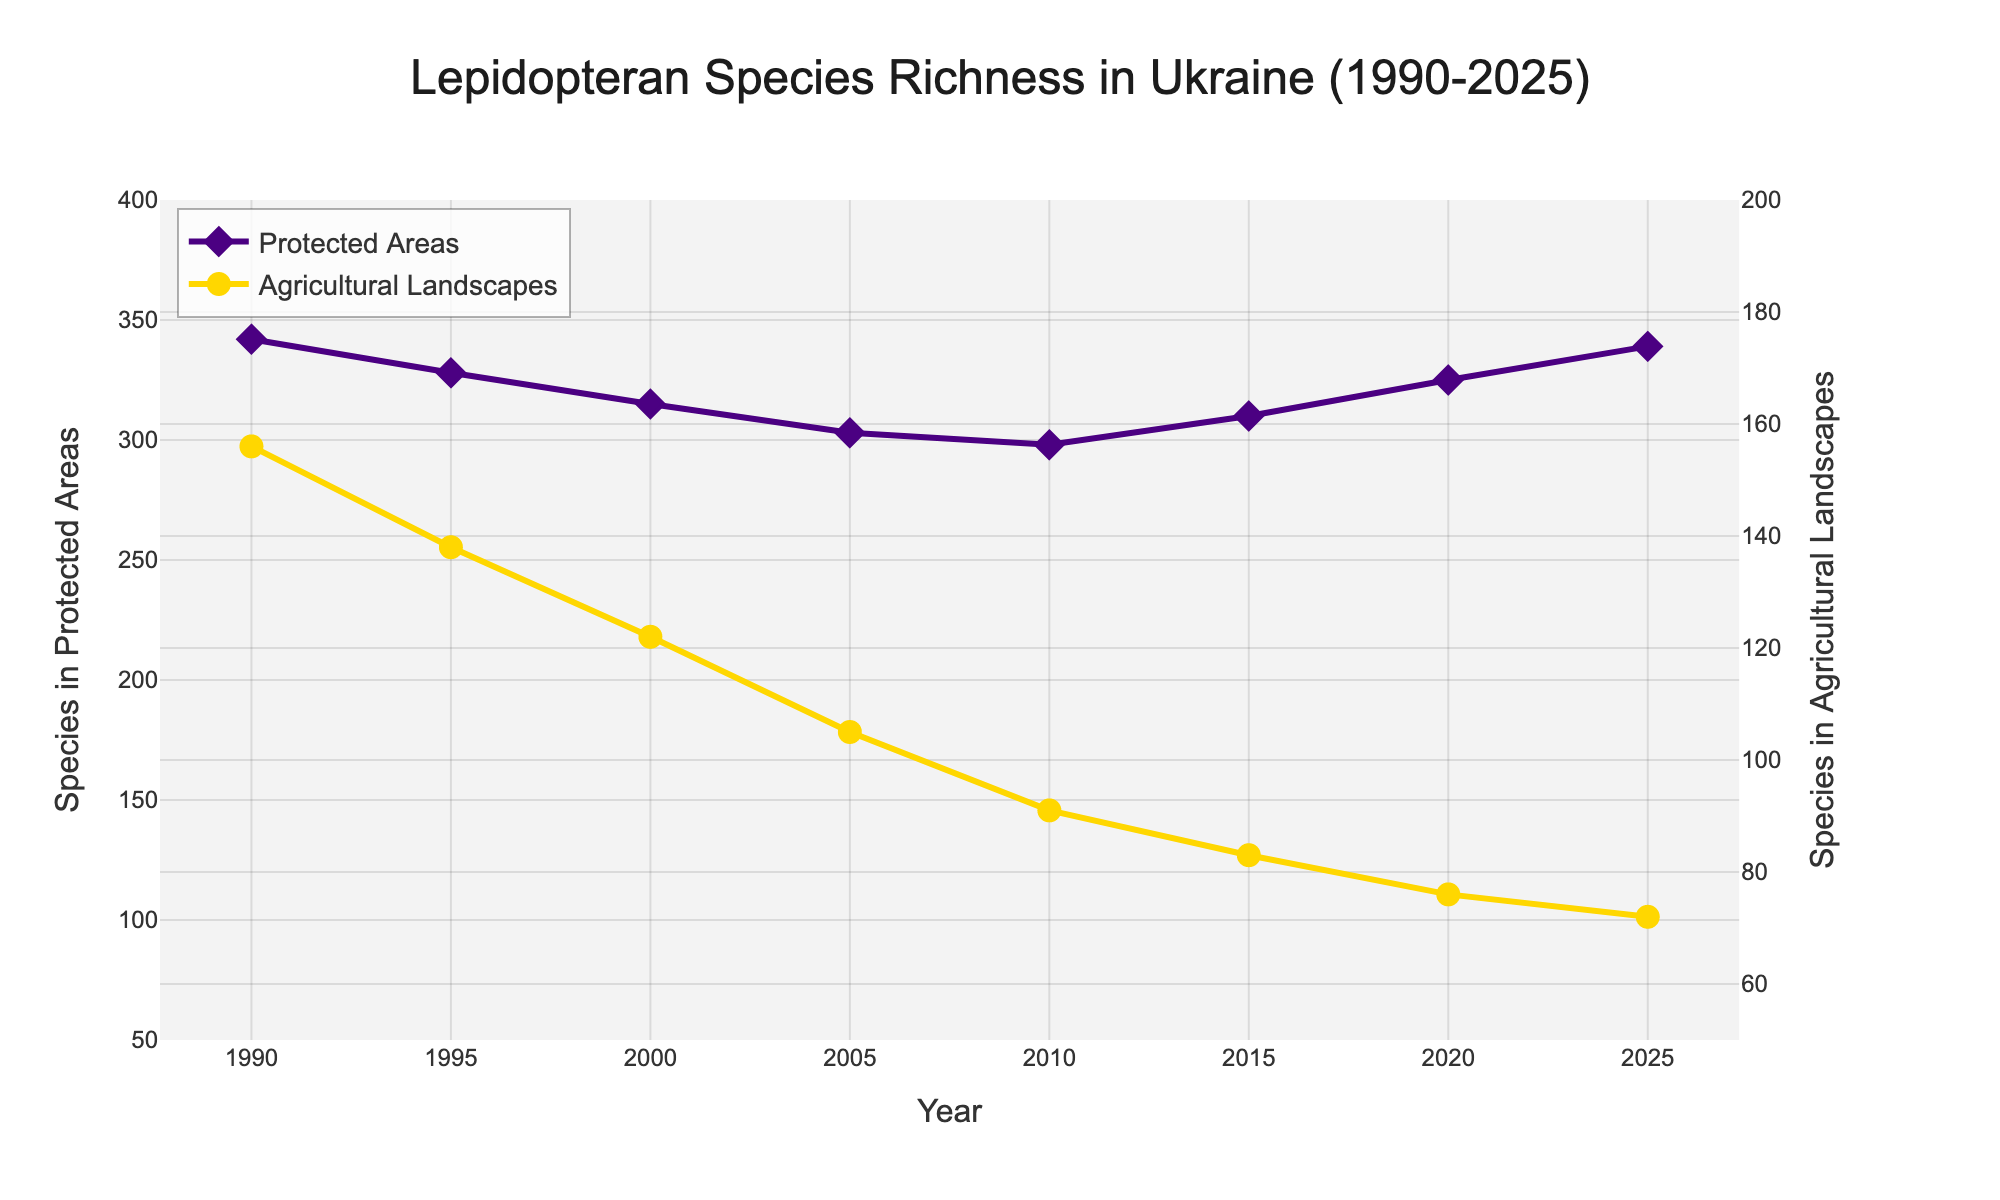What is the overall trend of lepidopteran species richness in Protected Areas from 1990 to 2025? The line for Protected Areas shows a generally decreasing trend from 1990 to 2010, after which there is a recovery and increasing trend up to 2025. Observing data points, it starts at 342 in 1990, drops to 298 in 2010, and then increases to 339 in 2025.
Answer: Decreasing then Increasing By how much did the lepidopteran species richness in Protected Areas reduce from 1990 to 2010? In 1990, the number of species in Protected Areas was 342, and in 2010 it was 298. The reduction can be calculated as 342 - 298.
Answer: 44 Which year shows the highest species richness in Agricultural Landscapes? By analyzing the data points on the chart for Agricultural Landscapes, it is evident that 1990 had the highest species richness with 156 species.
Answer: 1990 By what percentage did the species richness in Agricultural Landscapes decrease from 1990 to 2025? The species richness decreased from 156 in 1990 to 72 in 2025. The percentage decrease can be calculated as ((156 - 72) / 156) * 100.
Answer: 53.85% What is the difference in lepidopteran species richness between Protected Areas and Agricultural Landscapes in the year 2015? The species richness in Protected Areas in 2015 was 310, and in Agricultural Landscapes, it was 83. The difference is calculated as 310 - 83.
Answer: 227 In which year did the lepidopteran species richness in Protected Areas hit the lowest point? The lowest point for species richness in Protected Areas is in 2010, where the number was 298.
Answer: 2010 Compare the trends in species richness in Protected Areas and Agricultural Landscapes from 1990 to 2005. During 1990 to 2005, species richness in both areas decreases. In Protected Areas, it goes from 342 in 1990 to 303 in 2005, while in Agricultural Landscapes, it goes from 156 to 105 in the same period.
Answer: Both Decrease What visual features are used to distinguish the two areas (Protected vs Agricultural) on the plot? The line for Protected Areas is represented by indigo color with diamond markers, whereas the line for Agricultural Landscapes is represented by golden color with circle markers.
Answer: Color and Marker Type Calculate the average species richness in Protected Areas over the entire period (1990-2025). Add up the values for every year in Protected Areas (342 + 328 + 315 + 303 + 298 + 310 + 325 + 339) and divide by the number of years (8).
Answer: 320 What is the overall trend in Agricultural Landscapes' species richness from 1990 to 2025? The chart shows a continuous decreasing trend in species richness in Agricultural Landscapes from 1990 (156 species) to 2025 (72 species).
Answer: Decreasing 